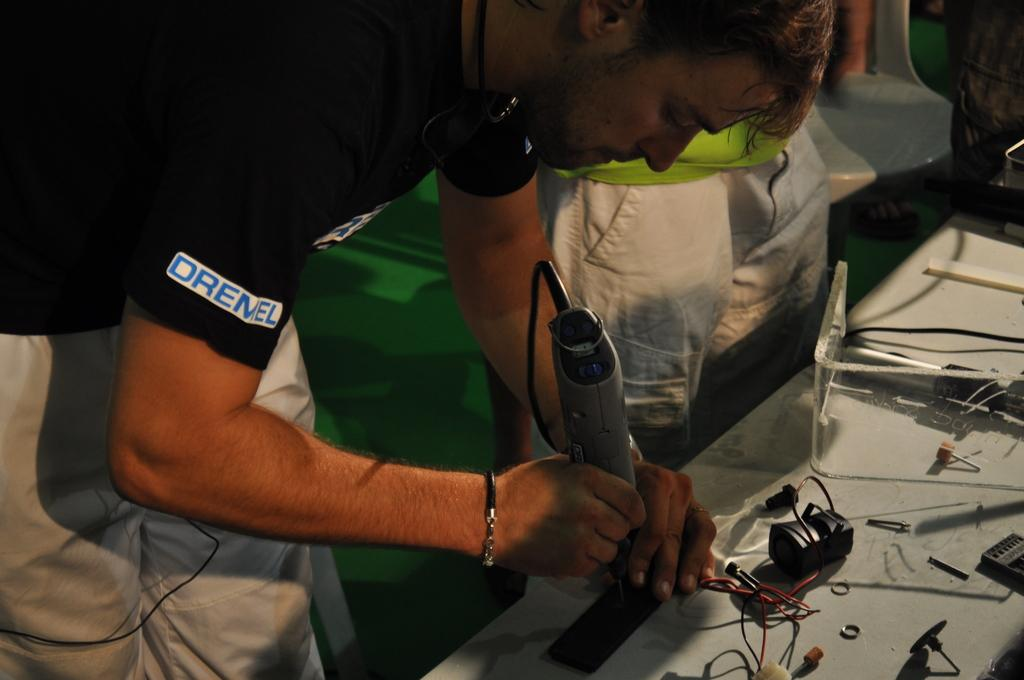<image>
Render a clear and concise summary of the photo. A man wearing a balck shirt with the word, "Dremel" as he holds a power tool. 